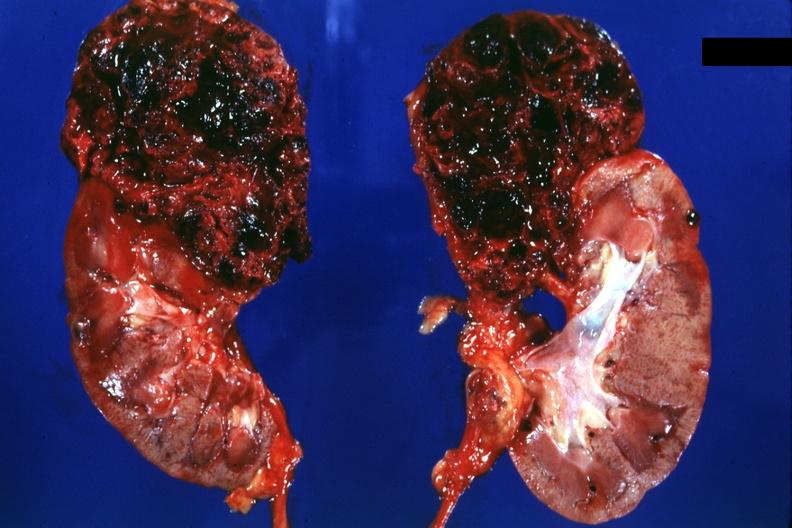does musculoskeletal show two halves of kidney with superior pole very hemorrhagic tumor?
Answer the question using a single word or phrase. No 